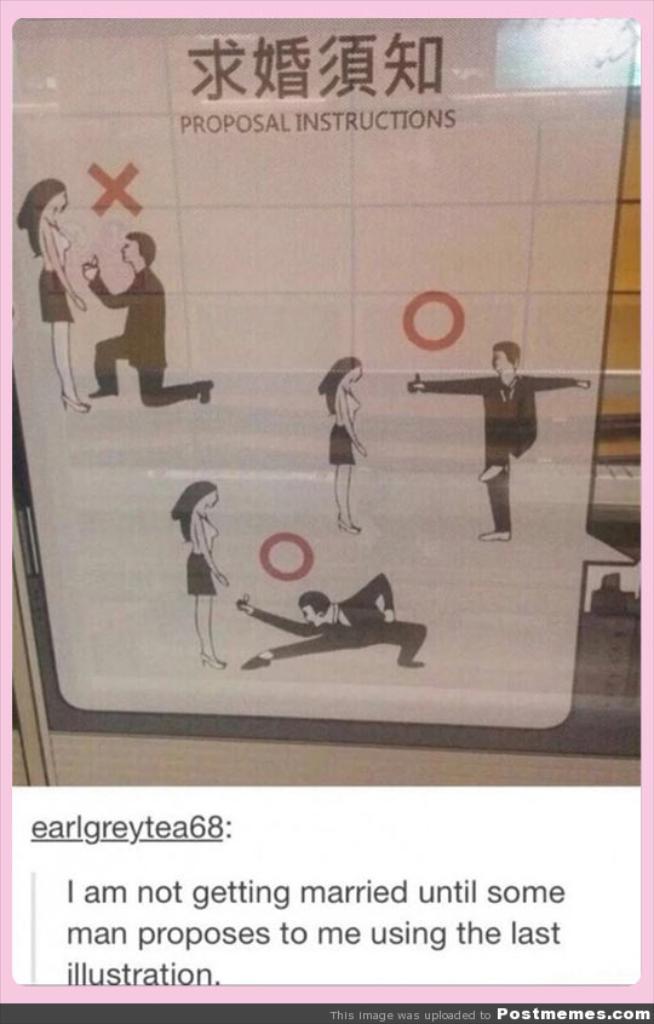<image>
Describe the image concisely. A white poster entitled PROPOSAL INSTRUCTIONS with images of a man proposing to a woman 